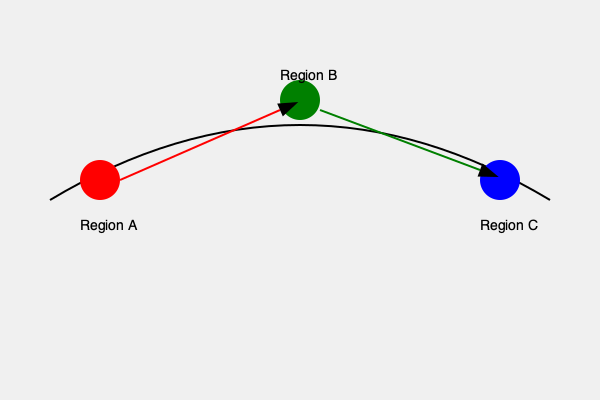Based on the migration pattern shown in the map, which cultural practice is most likely to diffuse from Region A to Region C, assuming Region B acts as an intermediary? To answer this question, we need to analyze the migration pattern and understand the concept of cultural diffusion:

1. Migration pattern:
   - The map shows a movement from Region A to Region B, and then from Region B to Region C.
   - This suggests a step-wise migration or cultural transmission process.

2. Cultural diffusion:
   - Cultural diffusion is the spread of cultural elements (ideas, styles, technologies, etc.) from one group or area to another.
   - In this case, we see a potential for cultural elements to move from A to B, and then from B to C.

3. Intermediary role of Region B:
   - Region B receives cultural elements from Region A and potentially passes them on to Region C.
   - However, Region B may modify or adapt these elements before transmitting them further.

4. Likelihood of cultural practice diffusion:
   - Practices that are more easily transmitted and adapted are more likely to diffuse across multiple regions.
   - Examples include:
     a) Language elements (e.g., loanwords)
     b) Religious or spiritual beliefs
     c) Technological innovations
     d) Artistic styles or motifs
     e) Culinary practices

5. Most likely practice to diffuse:
   - Among these, technological innovations are often the most likely to diffuse across multiple regions because:
     a) They offer practical benefits that can be easily recognized.
     b) They can be adopted without necessarily changing core cultural values.
     c) They are often adaptable to different cultural contexts.

Therefore, a technological innovation from Region A is most likely to diffuse to Region C through Region B, as it can be easily transmitted, adopted, and potentially adapted along the way.
Answer: Technological innovation 